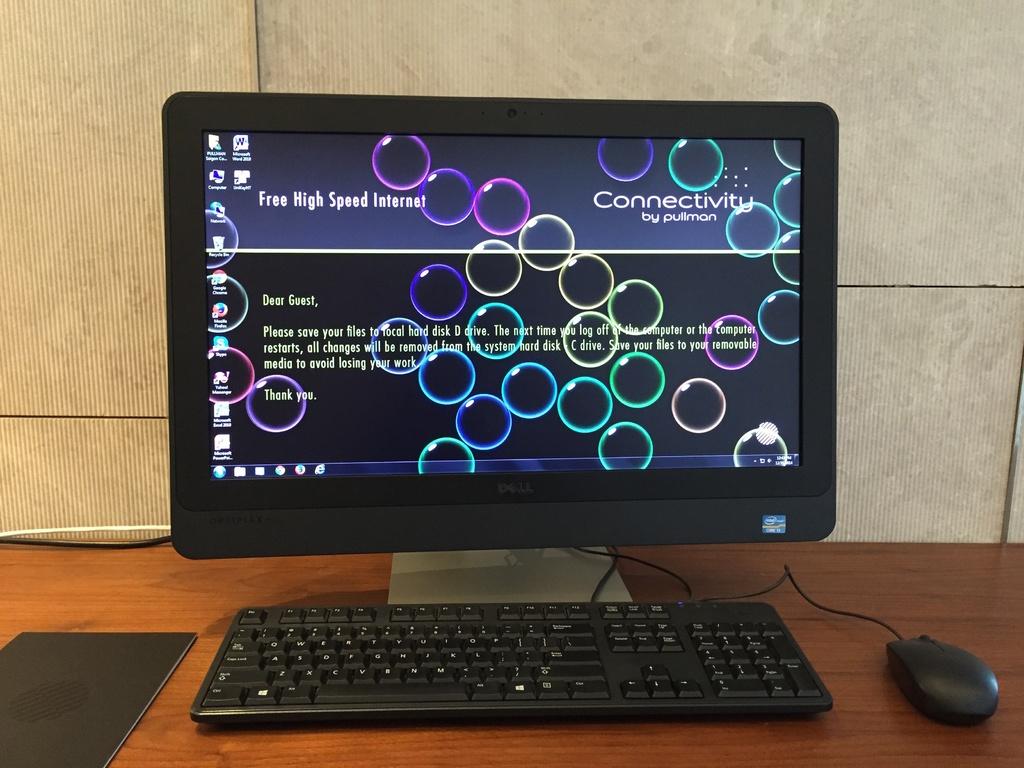Is this a work or home computer?
Provide a short and direct response. Work. What is the brand of the computer?
Make the answer very short. Dell. 